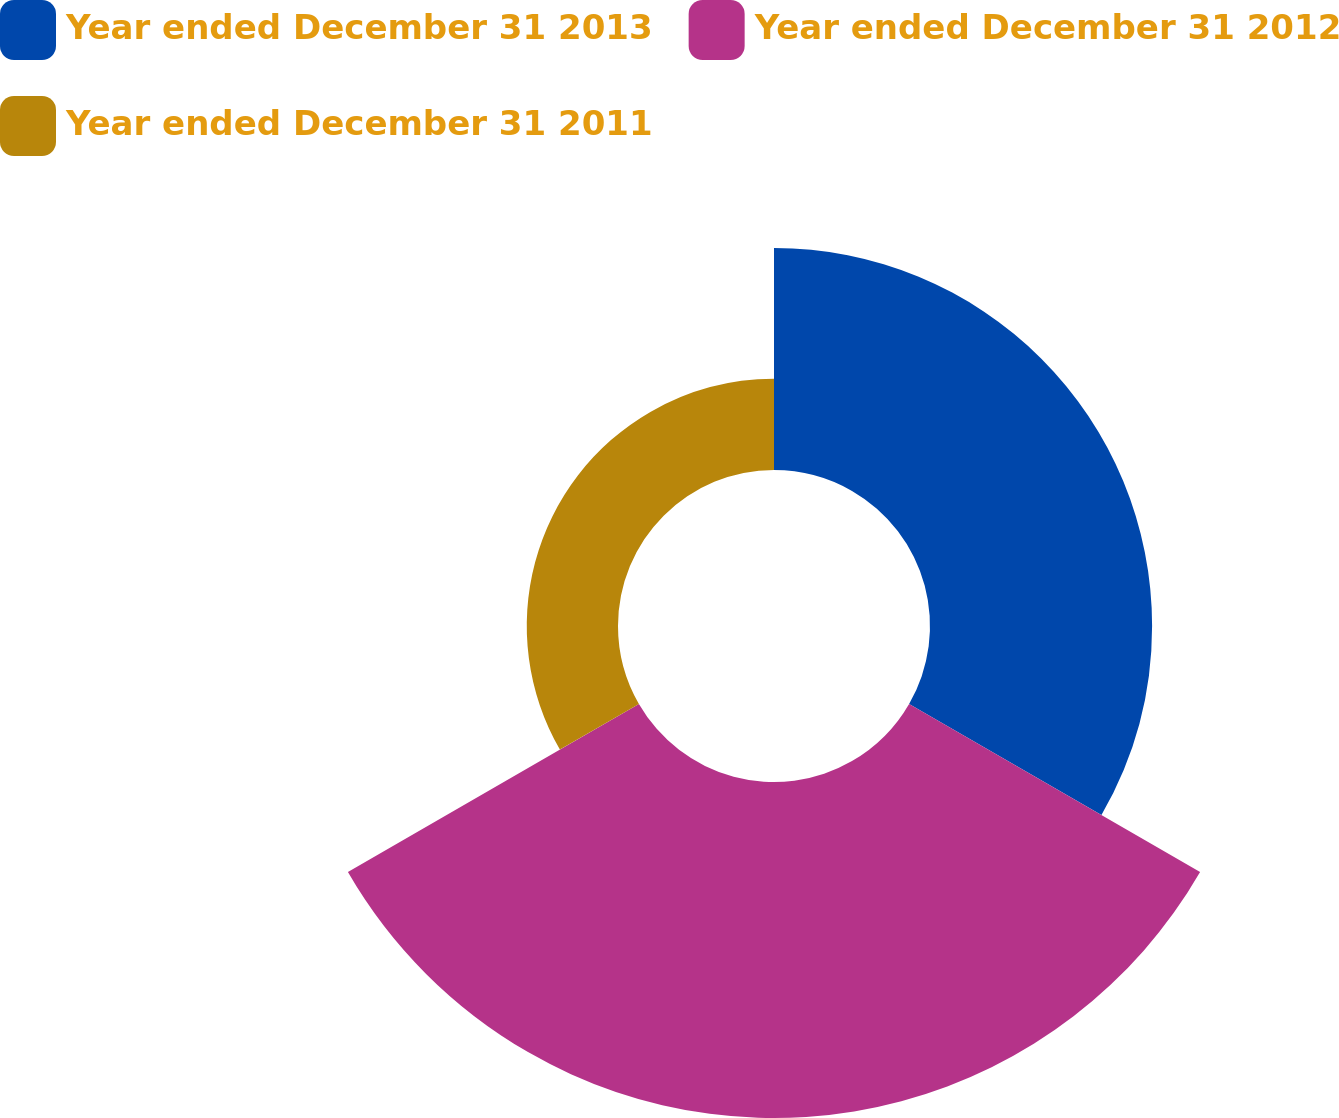Convert chart. <chart><loc_0><loc_0><loc_500><loc_500><pie_chart><fcel>Year ended December 31 2013<fcel>Year ended December 31 2012<fcel>Year ended December 31 2011<nl><fcel>34.2%<fcel>51.74%<fcel>14.05%<nl></chart> 